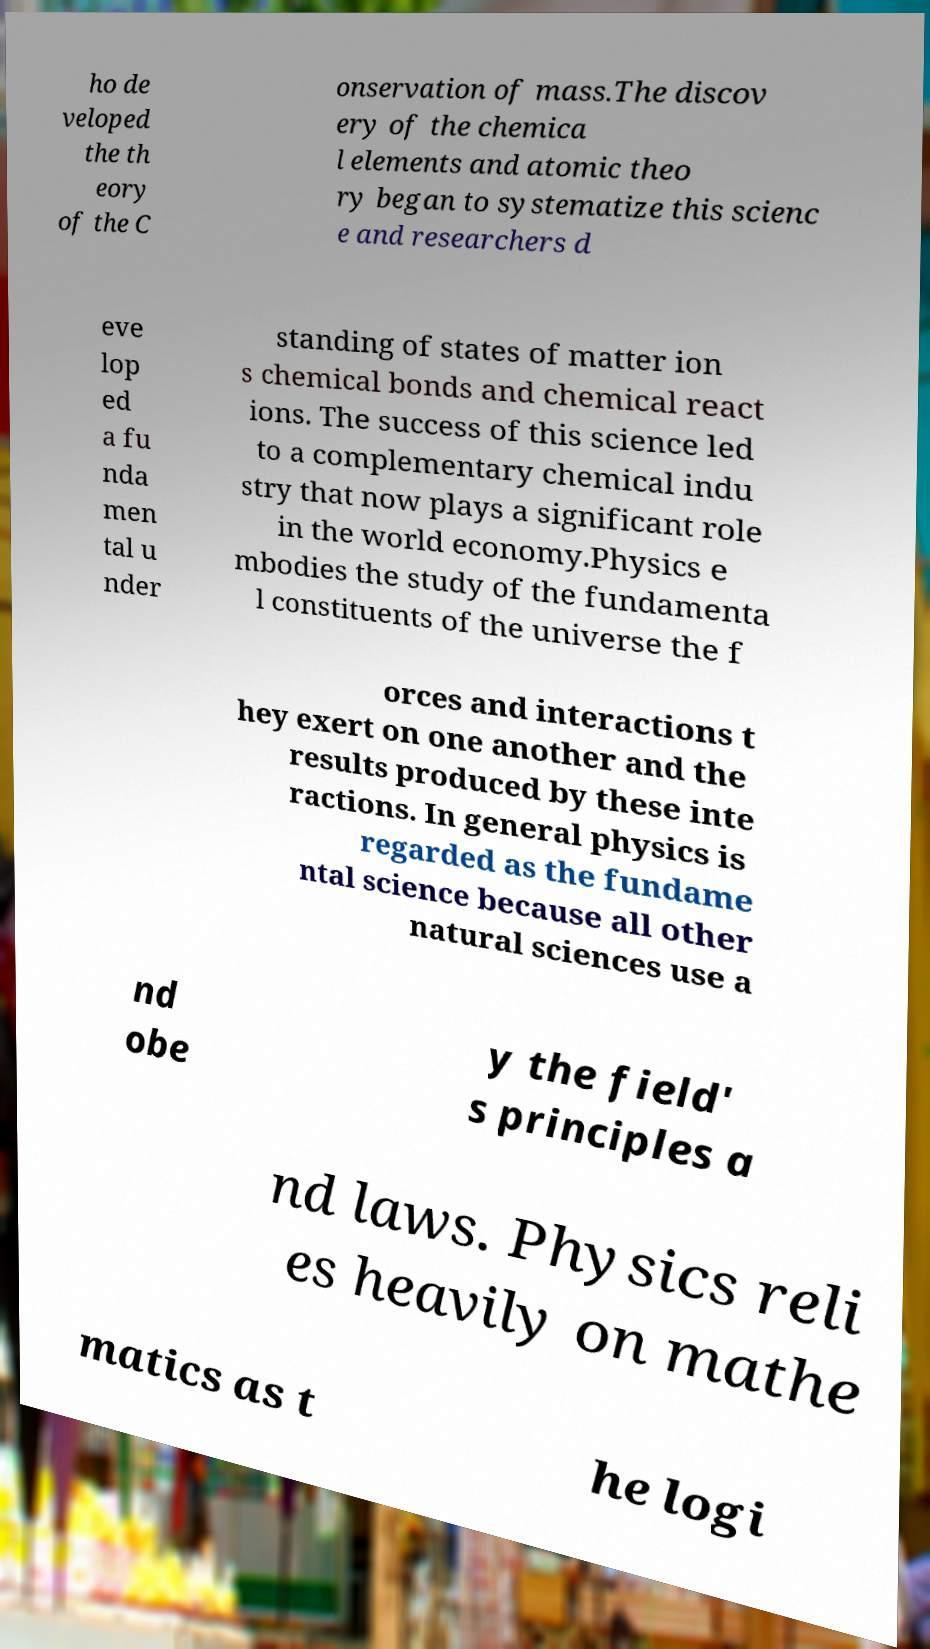Can you accurately transcribe the text from the provided image for me? ho de veloped the th eory of the C onservation of mass.The discov ery of the chemica l elements and atomic theo ry began to systematize this scienc e and researchers d eve lop ed a fu nda men tal u nder standing of states of matter ion s chemical bonds and chemical react ions. The success of this science led to a complementary chemical indu stry that now plays a significant role in the world economy.Physics e mbodies the study of the fundamenta l constituents of the universe the f orces and interactions t hey exert on one another and the results produced by these inte ractions. In general physics is regarded as the fundame ntal science because all other natural sciences use a nd obe y the field' s principles a nd laws. Physics reli es heavily on mathe matics as t he logi 